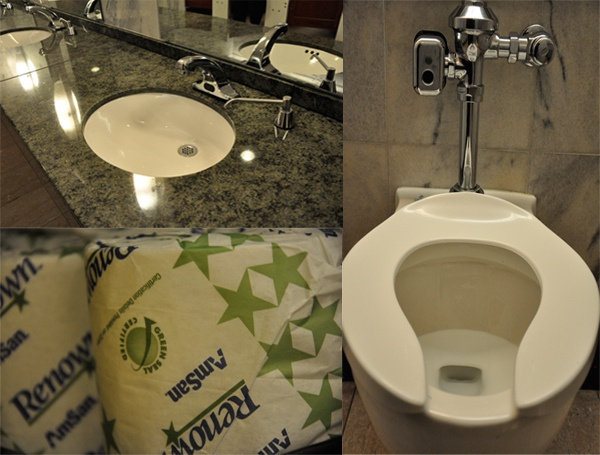Describe the objects in this image and their specific colors. I can see toilet in gray, tan, and olive tones, sink in gray and tan tones, sink in gray, tan, and black tones, and sink in gray, tan, and black tones in this image. 